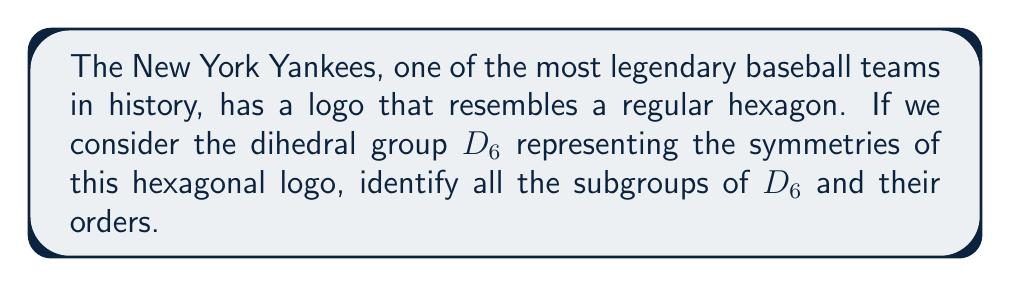What is the answer to this math problem? Let's approach this step-by-step:

1) First, recall that the dihedral group $D_6$ has order 12. It consists of 6 rotations (including the identity) and 6 reflections.

2) The elements of $D_6$ can be represented as:
   $$D_6 = \{e, r, r^2, r^3, r^4, r^5, s, sr, sr^2, sr^3, sr^4, sr^5\}$$
   where $r$ represents a rotation by 60° and $s$ represents a reflection.

3) To find the subgroups, we need to consider the possible orders of subgroups. By Lagrange's theorem, the order of a subgroup must divide the order of the group. So, the possible orders are 1, 2, 3, 4, 6, and 12.

4) Let's identify the subgroups:

   a) Order 1: $\{e\}$ (the trivial subgroup)

   b) Order 2: 
      - $\{e, r^3\}$ (180° rotation)
      - $\{e, s\}, \{e, sr\}, \{e, sr^2\}, \{e, sr^3\}, \{e, sr^4\}, \{e, sr^5\}$ (6 reflection subgroups)

   c) Order 3: $\{e, r^2, r^4\}$

   d) Order 4: $\{e, r^3, s, sr^3\}, \{e, r^3, sr, sr^4\}, \{e, r^3, sr^2, sr^5\}$

   e) Order 6: 
      - $\{e, r, r^2, r^3, r^4, r^5\}$ (rotations)
      - $\{e, r^2, r^4, s, sr^2, sr^4\}, \{e, r^2, r^4, sr, sr^3, sr^5\}$

   f) Order 12: The entire group $D_6$

5) In total, we have:
   1 subgroup of order 1
   7 subgroups of order 2
   1 subgroup of order 3
   3 subgroups of order 4
   3 subgroups of order 6
   1 subgroup of order 12

Therefore, $D_6$ has 16 subgroups in total.
Answer: $D_6$ has 16 subgroups: 1 of order 1, 7 of order 2, 1 of order 3, 3 of order 4, 3 of order 6, and 1 of order 12. 